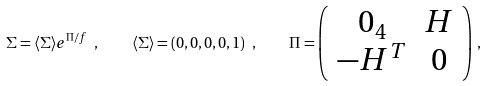<formula> <loc_0><loc_0><loc_500><loc_500>\Sigma = \langle \Sigma \rangle e ^ { \Pi / f } \ , \quad \langle \Sigma \rangle = ( 0 , 0 , 0 , 0 , 1 ) \ , \quad \Pi = \left ( \begin{array} { c c } 0 _ { 4 } & H \\ - H ^ { T } & 0 \\ \end{array} \right ) \, ,</formula> 